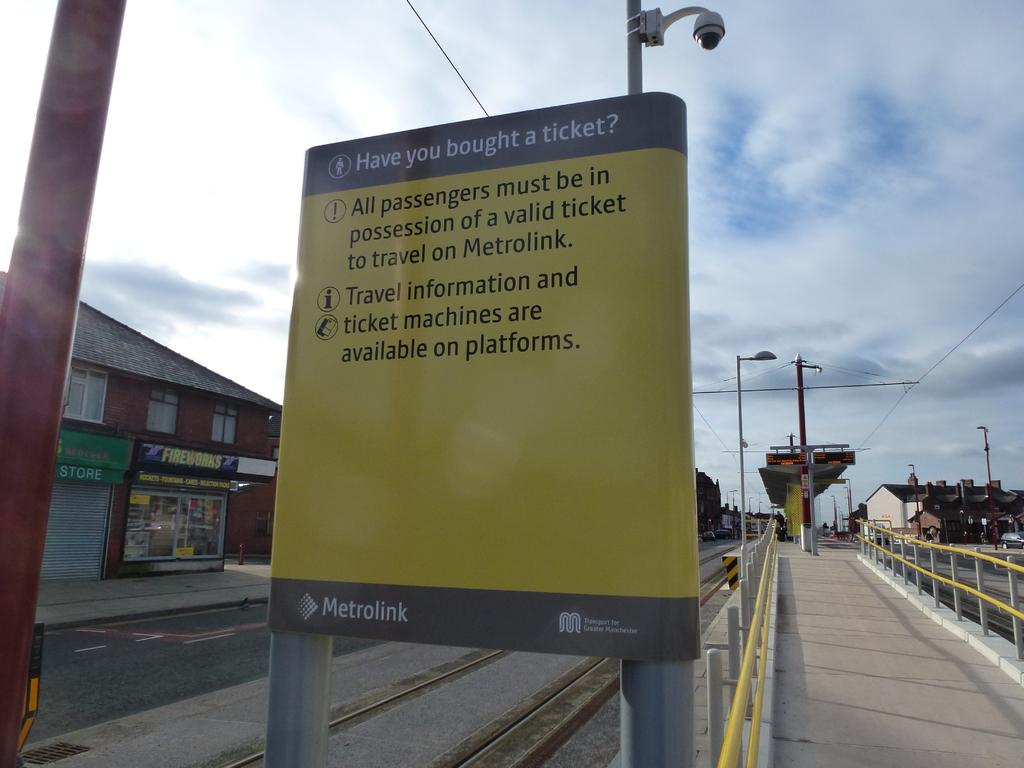What is the sign reminding you of?
Provide a short and direct response. To buy a ticket. What must every passenger have to travel on the metrolink?
Keep it short and to the point. Valid ticket. 